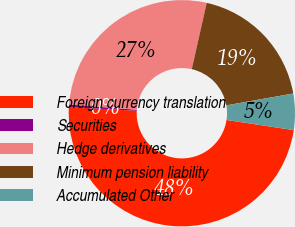Convert chart. <chart><loc_0><loc_0><loc_500><loc_500><pie_chart><fcel>Foreign currency translation<fcel>Securities<fcel>Hedge derivatives<fcel>Minimum pension liability<fcel>Accumulated Other<nl><fcel>48.49%<fcel>0.36%<fcel>27.3%<fcel>18.68%<fcel>5.17%<nl></chart> 